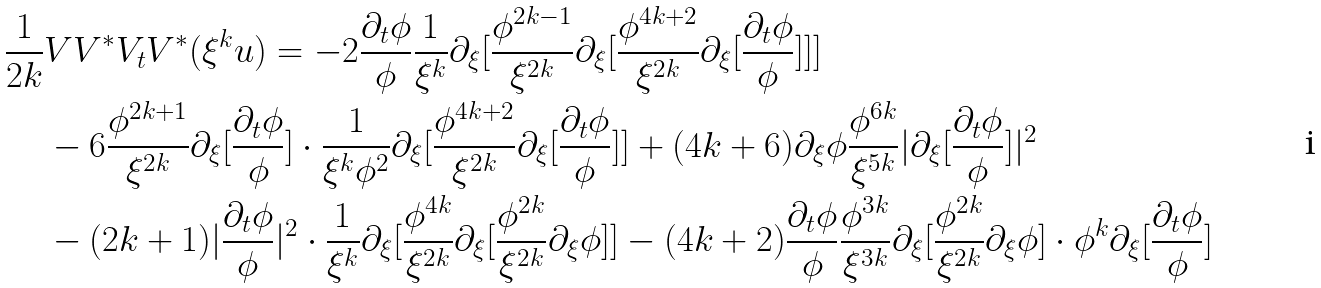Convert formula to latex. <formula><loc_0><loc_0><loc_500><loc_500>\frac { 1 } { 2 k } & V V ^ { \ast } V _ { t } V ^ { \ast } ( \xi ^ { k } u ) = - 2 \frac { \partial _ { t } \phi } { \phi } \frac { 1 } { \xi ^ { k } } \partial _ { \xi } [ \frac { \phi ^ { 2 k - 1 } } { \xi ^ { 2 k } } \partial _ { \xi } [ \frac { \phi ^ { 4 k + 2 } } { \xi ^ { 2 k } } \partial _ { \xi } [ \frac { \partial _ { t } \phi } { \phi } ] ] ] \\ & - 6 \frac { \phi ^ { 2 k + 1 } } { \xi ^ { 2 k } } \partial _ { \xi } [ \frac { \partial _ { t } \phi } { \phi } ] \cdot \frac { 1 } { \xi ^ { k } \phi ^ { 2 } } \partial _ { \xi } [ \frac { \phi ^ { 4 k + 2 } } { \xi ^ { 2 k } } \partial _ { \xi } [ \frac { \partial _ { t } \phi } { \phi } ] ] + ( 4 k + 6 ) \partial _ { \xi } \phi \frac { \phi ^ { 6 k } } { \xi ^ { 5 k } } | \partial _ { \xi } [ \frac { \partial _ { t } \phi } { \phi } ] | ^ { 2 } \\ & - ( 2 k + 1 ) | \frac { \partial _ { t } \phi } { \phi } | ^ { 2 } \cdot \frac { 1 } { \xi ^ { k } } \partial _ { \xi } [ \frac { \phi ^ { 4 k } } { \xi ^ { 2 k } } \partial _ { \xi } [ \frac { \phi ^ { 2 k } } { \xi ^ { 2 k } } \partial _ { \xi } \phi ] ] - ( 4 k + 2 ) \frac { \partial _ { t } \phi } { \phi } \frac { \phi ^ { 3 k } } { \xi ^ { 3 k } } \partial _ { \xi } [ \frac { \phi ^ { 2 k } } { \xi ^ { 2 k } } \partial _ { \xi } \phi ] \cdot \phi ^ { k } \partial _ { \xi } [ \frac { \partial _ { t } \phi } { \phi } ]</formula> 